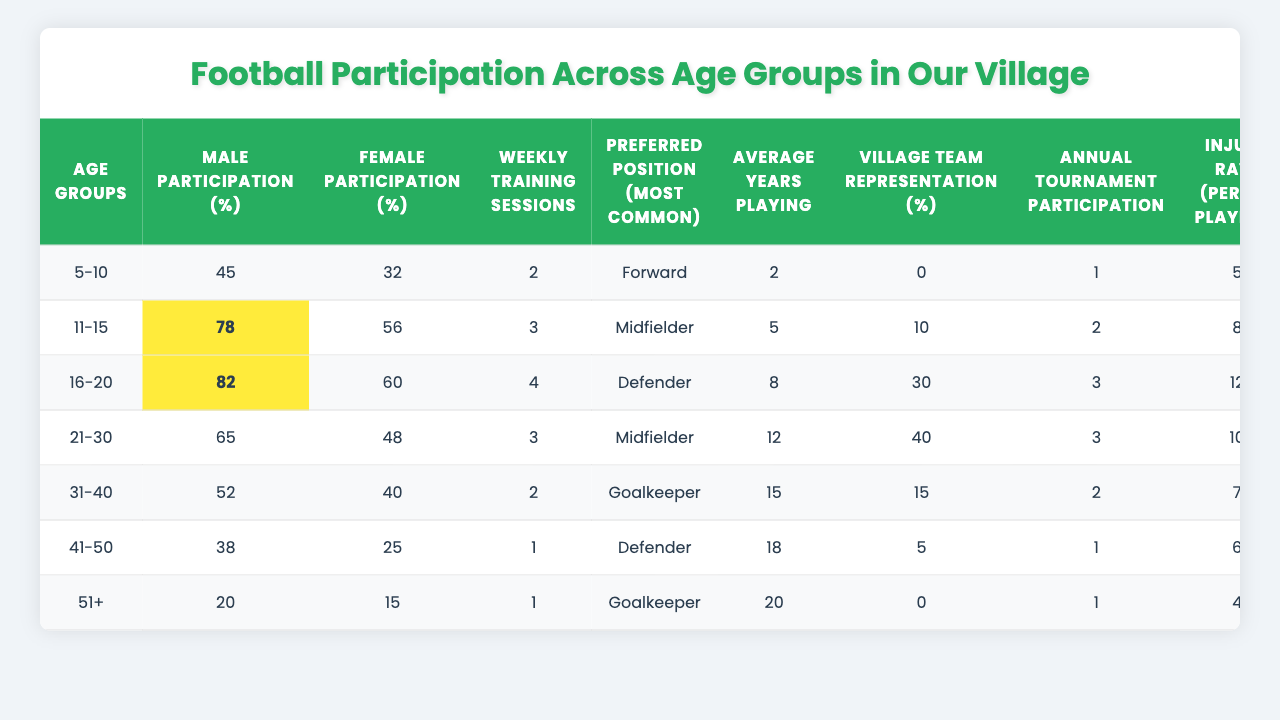What is the male participation rate for the 21-30 age group? The table shows that the male participation rate for the 21-30 age group is 65%.
Answer: 65% What is the preferred position for the 16-20 age group? For the 16-20 age group, the most common preferred position listed in the table is Defender.
Answer: Defender Which age group has the highest female participation percentage? The 11-15 age group has the highest female participation percentage, which is 56%.
Answer: 11-15 What is the average number of weekly training sessions across all age groups? To find the average, sum the weekly training sessions (2 + 3 + 4 + 3 + 2 + 1 + 1 = 16) and divide by the number of age groups (7). Thus, the average is 16/7 ≈ 2.29.
Answer: 2.29 In which age group do the majority of players have the most years of playing experience? The 51+ age group has the highest average years playing, totaling 20 years.
Answer: 51+ What percentage of males participate in football from the 41-50 age group? The table specifies that 38% of males participate in football from the 41-50 age group.
Answer: 38% Is the injury rate higher in the 16-20 age group compared to the 11-15 age group? Yes, the injury rate in the 16-20 age group is 12 per 100 players, while in the 11-15 age group it is 8.
Answer: Yes What is the difference in village team representation between the 16-20 and 31-40 age groups? The village team representation for the 16-20 age group is 30% and for the 31-40 age group is 15%. The difference is 30% - 15% = 15%.
Answer: 15% How many age groups have an annual tournament participation of 2? There are two age groups, 21-30 and 31-40, with an annual tournament participation of 2 each as indicated in the table.
Answer: 2 If we consider only the female participation rates, what is the median value across all age groups? The female participation rates are 32, 56, 60, 48, 40, 25, 15. When sorted, the values are 15, 25, 32, 40, 48, 56, 60. The median (middle value) is 40.
Answer: 40 What can we infer about community coach involvement in the age group with the lowest male participation? The lowest male participation is in the 51+ age group, which has only 5% community coach involvement, suggesting limited engagement.
Answer: Limited engagement 